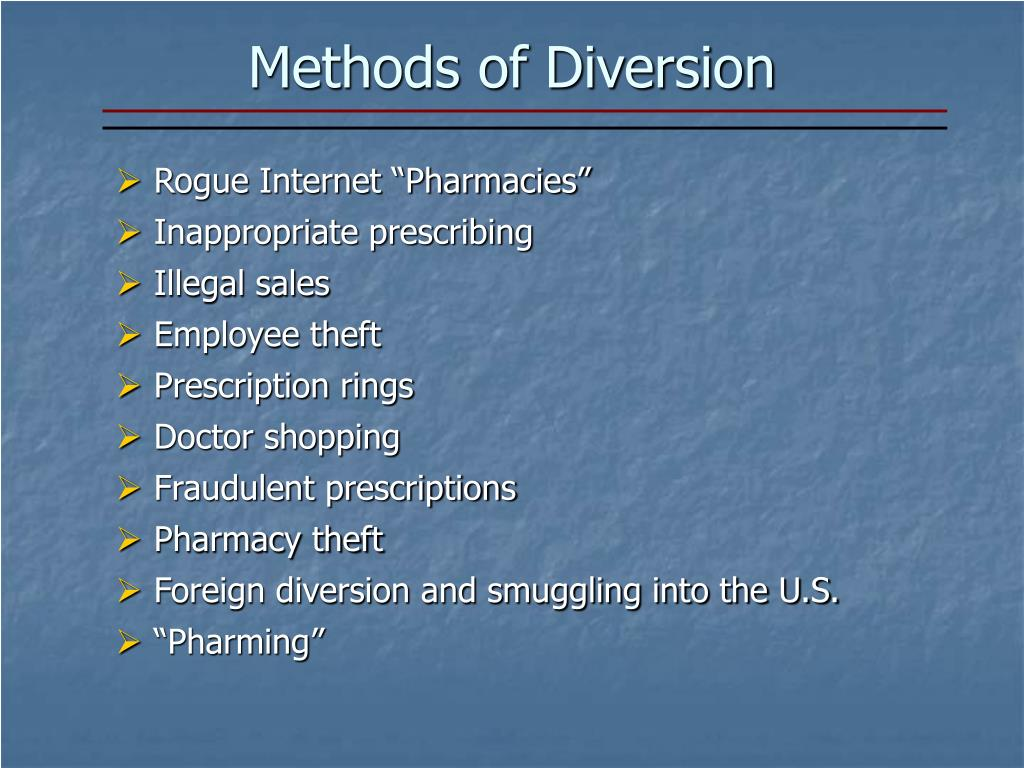What creative strategies could be implemented to combat 'Foreign diversion and smuggling into the U.S.'? To combat 'Foreign diversion and smuggling into the U.S.', several innovative strategies could be deployed. For instance, leveraging advanced technology like blockchain can enhance the traceability of pharmaceutical products from production to end-user, making it harder to divert them illegally. Additionally, artificial intelligence and machine learning algorithms can identify suspicious patterns and flag potential instances of smuggling based on data analysis. Strengthening international agreements and establishing a centralized global database for tracking prescription drugs can also greatly enhance cooperation across borders. Moreover, public awareness campaigns can educate individuals about the dangers of using diverted medications. Collaborating with tech companies to develop real-time reporting apps can empower consumers and healthcare providers to report suspected diversion, thus aiding in swift action and response. 